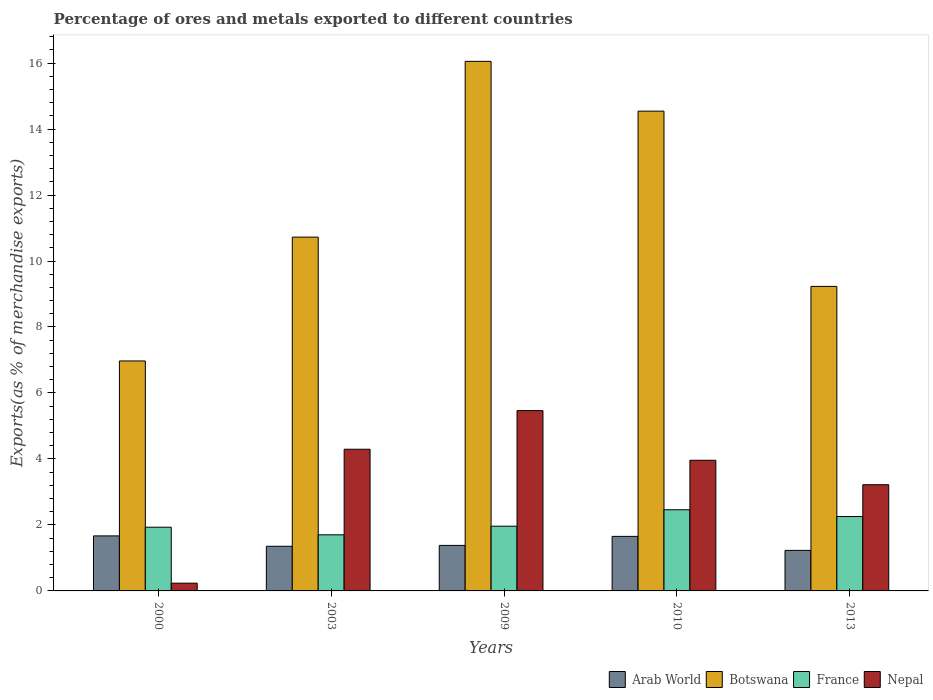Are the number of bars on each tick of the X-axis equal?
Your answer should be very brief. Yes. How many bars are there on the 1st tick from the left?
Offer a terse response. 4. How many bars are there on the 5th tick from the right?
Provide a short and direct response. 4. What is the percentage of exports to different countries in Nepal in 2009?
Ensure brevity in your answer.  5.47. Across all years, what is the maximum percentage of exports to different countries in Arab World?
Keep it short and to the point. 1.67. Across all years, what is the minimum percentage of exports to different countries in France?
Make the answer very short. 1.7. In which year was the percentage of exports to different countries in France minimum?
Keep it short and to the point. 2003. What is the total percentage of exports to different countries in Botswana in the graph?
Provide a short and direct response. 57.52. What is the difference between the percentage of exports to different countries in Nepal in 2000 and that in 2009?
Your response must be concise. -5.23. What is the difference between the percentage of exports to different countries in Arab World in 2003 and the percentage of exports to different countries in France in 2009?
Provide a short and direct response. -0.61. What is the average percentage of exports to different countries in Nepal per year?
Make the answer very short. 3.43. In the year 2003, what is the difference between the percentage of exports to different countries in Nepal and percentage of exports to different countries in France?
Offer a terse response. 2.59. In how many years, is the percentage of exports to different countries in France greater than 3.2 %?
Give a very brief answer. 0. What is the ratio of the percentage of exports to different countries in Arab World in 2000 to that in 2010?
Give a very brief answer. 1.01. Is the difference between the percentage of exports to different countries in Nepal in 2000 and 2013 greater than the difference between the percentage of exports to different countries in France in 2000 and 2013?
Your answer should be compact. No. What is the difference between the highest and the second highest percentage of exports to different countries in Botswana?
Keep it short and to the point. 1.51. What is the difference between the highest and the lowest percentage of exports to different countries in Botswana?
Make the answer very short. 9.08. Is it the case that in every year, the sum of the percentage of exports to different countries in Botswana and percentage of exports to different countries in Nepal is greater than the sum of percentage of exports to different countries in Arab World and percentage of exports to different countries in France?
Provide a short and direct response. Yes. What does the 4th bar from the left in 2003 represents?
Offer a very short reply. Nepal. What does the 3rd bar from the right in 2003 represents?
Your response must be concise. Botswana. How many bars are there?
Your response must be concise. 20. How many years are there in the graph?
Give a very brief answer. 5. What is the difference between two consecutive major ticks on the Y-axis?
Your answer should be very brief. 2. Does the graph contain any zero values?
Ensure brevity in your answer.  No. Does the graph contain grids?
Offer a very short reply. No. Where does the legend appear in the graph?
Your answer should be compact. Bottom right. How are the legend labels stacked?
Provide a succinct answer. Horizontal. What is the title of the graph?
Give a very brief answer. Percentage of ores and metals exported to different countries. What is the label or title of the X-axis?
Offer a very short reply. Years. What is the label or title of the Y-axis?
Your answer should be very brief. Exports(as % of merchandise exports). What is the Exports(as % of merchandise exports) of Arab World in 2000?
Provide a succinct answer. 1.67. What is the Exports(as % of merchandise exports) in Botswana in 2000?
Your response must be concise. 6.97. What is the Exports(as % of merchandise exports) in France in 2000?
Give a very brief answer. 1.93. What is the Exports(as % of merchandise exports) of Nepal in 2000?
Your answer should be compact. 0.23. What is the Exports(as % of merchandise exports) in Arab World in 2003?
Provide a succinct answer. 1.35. What is the Exports(as % of merchandise exports) in Botswana in 2003?
Your response must be concise. 10.72. What is the Exports(as % of merchandise exports) in France in 2003?
Provide a short and direct response. 1.7. What is the Exports(as % of merchandise exports) of Nepal in 2003?
Provide a short and direct response. 4.29. What is the Exports(as % of merchandise exports) in Arab World in 2009?
Your answer should be compact. 1.38. What is the Exports(as % of merchandise exports) in Botswana in 2009?
Offer a terse response. 16.05. What is the Exports(as % of merchandise exports) of France in 2009?
Provide a short and direct response. 1.96. What is the Exports(as % of merchandise exports) of Nepal in 2009?
Make the answer very short. 5.47. What is the Exports(as % of merchandise exports) of Arab World in 2010?
Offer a terse response. 1.65. What is the Exports(as % of merchandise exports) of Botswana in 2010?
Give a very brief answer. 14.54. What is the Exports(as % of merchandise exports) in France in 2010?
Keep it short and to the point. 2.46. What is the Exports(as % of merchandise exports) in Nepal in 2010?
Provide a succinct answer. 3.96. What is the Exports(as % of merchandise exports) of Arab World in 2013?
Offer a terse response. 1.23. What is the Exports(as % of merchandise exports) of Botswana in 2013?
Keep it short and to the point. 9.23. What is the Exports(as % of merchandise exports) in France in 2013?
Offer a very short reply. 2.25. What is the Exports(as % of merchandise exports) of Nepal in 2013?
Offer a terse response. 3.22. Across all years, what is the maximum Exports(as % of merchandise exports) in Arab World?
Give a very brief answer. 1.67. Across all years, what is the maximum Exports(as % of merchandise exports) of Botswana?
Offer a terse response. 16.05. Across all years, what is the maximum Exports(as % of merchandise exports) in France?
Your answer should be compact. 2.46. Across all years, what is the maximum Exports(as % of merchandise exports) in Nepal?
Offer a very short reply. 5.47. Across all years, what is the minimum Exports(as % of merchandise exports) of Arab World?
Offer a terse response. 1.23. Across all years, what is the minimum Exports(as % of merchandise exports) of Botswana?
Give a very brief answer. 6.97. Across all years, what is the minimum Exports(as % of merchandise exports) of France?
Make the answer very short. 1.7. Across all years, what is the minimum Exports(as % of merchandise exports) of Nepal?
Give a very brief answer. 0.23. What is the total Exports(as % of merchandise exports) of Arab World in the graph?
Provide a succinct answer. 7.28. What is the total Exports(as % of merchandise exports) in Botswana in the graph?
Make the answer very short. 57.52. What is the total Exports(as % of merchandise exports) in France in the graph?
Give a very brief answer. 10.31. What is the total Exports(as % of merchandise exports) in Nepal in the graph?
Your answer should be compact. 17.17. What is the difference between the Exports(as % of merchandise exports) in Arab World in 2000 and that in 2003?
Your answer should be compact. 0.31. What is the difference between the Exports(as % of merchandise exports) of Botswana in 2000 and that in 2003?
Your answer should be compact. -3.75. What is the difference between the Exports(as % of merchandise exports) of France in 2000 and that in 2003?
Provide a short and direct response. 0.23. What is the difference between the Exports(as % of merchandise exports) of Nepal in 2000 and that in 2003?
Ensure brevity in your answer.  -4.06. What is the difference between the Exports(as % of merchandise exports) in Arab World in 2000 and that in 2009?
Offer a very short reply. 0.29. What is the difference between the Exports(as % of merchandise exports) of Botswana in 2000 and that in 2009?
Make the answer very short. -9.08. What is the difference between the Exports(as % of merchandise exports) in France in 2000 and that in 2009?
Your response must be concise. -0.03. What is the difference between the Exports(as % of merchandise exports) of Nepal in 2000 and that in 2009?
Keep it short and to the point. -5.23. What is the difference between the Exports(as % of merchandise exports) in Arab World in 2000 and that in 2010?
Make the answer very short. 0.01. What is the difference between the Exports(as % of merchandise exports) of Botswana in 2000 and that in 2010?
Keep it short and to the point. -7.57. What is the difference between the Exports(as % of merchandise exports) of France in 2000 and that in 2010?
Your response must be concise. -0.53. What is the difference between the Exports(as % of merchandise exports) in Nepal in 2000 and that in 2010?
Ensure brevity in your answer.  -3.73. What is the difference between the Exports(as % of merchandise exports) in Arab World in 2000 and that in 2013?
Provide a succinct answer. 0.44. What is the difference between the Exports(as % of merchandise exports) in Botswana in 2000 and that in 2013?
Offer a terse response. -2.26. What is the difference between the Exports(as % of merchandise exports) of France in 2000 and that in 2013?
Offer a terse response. -0.32. What is the difference between the Exports(as % of merchandise exports) of Nepal in 2000 and that in 2013?
Your answer should be compact. -2.98. What is the difference between the Exports(as % of merchandise exports) of Arab World in 2003 and that in 2009?
Offer a very short reply. -0.03. What is the difference between the Exports(as % of merchandise exports) in Botswana in 2003 and that in 2009?
Give a very brief answer. -5.33. What is the difference between the Exports(as % of merchandise exports) in France in 2003 and that in 2009?
Provide a short and direct response. -0.26. What is the difference between the Exports(as % of merchandise exports) of Nepal in 2003 and that in 2009?
Your answer should be very brief. -1.17. What is the difference between the Exports(as % of merchandise exports) of Arab World in 2003 and that in 2010?
Provide a succinct answer. -0.3. What is the difference between the Exports(as % of merchandise exports) of Botswana in 2003 and that in 2010?
Your answer should be very brief. -3.82. What is the difference between the Exports(as % of merchandise exports) in France in 2003 and that in 2010?
Provide a short and direct response. -0.76. What is the difference between the Exports(as % of merchandise exports) in Nepal in 2003 and that in 2010?
Your answer should be compact. 0.33. What is the difference between the Exports(as % of merchandise exports) of Arab World in 2003 and that in 2013?
Your response must be concise. 0.12. What is the difference between the Exports(as % of merchandise exports) in Botswana in 2003 and that in 2013?
Your answer should be compact. 1.49. What is the difference between the Exports(as % of merchandise exports) in France in 2003 and that in 2013?
Provide a succinct answer. -0.55. What is the difference between the Exports(as % of merchandise exports) in Nepal in 2003 and that in 2013?
Offer a terse response. 1.07. What is the difference between the Exports(as % of merchandise exports) of Arab World in 2009 and that in 2010?
Ensure brevity in your answer.  -0.27. What is the difference between the Exports(as % of merchandise exports) in Botswana in 2009 and that in 2010?
Offer a very short reply. 1.51. What is the difference between the Exports(as % of merchandise exports) in France in 2009 and that in 2010?
Offer a very short reply. -0.5. What is the difference between the Exports(as % of merchandise exports) in Nepal in 2009 and that in 2010?
Your answer should be compact. 1.51. What is the difference between the Exports(as % of merchandise exports) in Arab World in 2009 and that in 2013?
Provide a succinct answer. 0.15. What is the difference between the Exports(as % of merchandise exports) in Botswana in 2009 and that in 2013?
Provide a short and direct response. 6.82. What is the difference between the Exports(as % of merchandise exports) in France in 2009 and that in 2013?
Give a very brief answer. -0.29. What is the difference between the Exports(as % of merchandise exports) in Nepal in 2009 and that in 2013?
Your answer should be very brief. 2.25. What is the difference between the Exports(as % of merchandise exports) of Arab World in 2010 and that in 2013?
Offer a terse response. 0.42. What is the difference between the Exports(as % of merchandise exports) of Botswana in 2010 and that in 2013?
Offer a terse response. 5.31. What is the difference between the Exports(as % of merchandise exports) of France in 2010 and that in 2013?
Provide a short and direct response. 0.21. What is the difference between the Exports(as % of merchandise exports) of Nepal in 2010 and that in 2013?
Provide a succinct answer. 0.74. What is the difference between the Exports(as % of merchandise exports) in Arab World in 2000 and the Exports(as % of merchandise exports) in Botswana in 2003?
Ensure brevity in your answer.  -9.06. What is the difference between the Exports(as % of merchandise exports) in Arab World in 2000 and the Exports(as % of merchandise exports) in France in 2003?
Offer a terse response. -0.03. What is the difference between the Exports(as % of merchandise exports) of Arab World in 2000 and the Exports(as % of merchandise exports) of Nepal in 2003?
Offer a very short reply. -2.63. What is the difference between the Exports(as % of merchandise exports) in Botswana in 2000 and the Exports(as % of merchandise exports) in France in 2003?
Your response must be concise. 5.27. What is the difference between the Exports(as % of merchandise exports) in Botswana in 2000 and the Exports(as % of merchandise exports) in Nepal in 2003?
Offer a terse response. 2.68. What is the difference between the Exports(as % of merchandise exports) of France in 2000 and the Exports(as % of merchandise exports) of Nepal in 2003?
Offer a terse response. -2.36. What is the difference between the Exports(as % of merchandise exports) of Arab World in 2000 and the Exports(as % of merchandise exports) of Botswana in 2009?
Give a very brief answer. -14.38. What is the difference between the Exports(as % of merchandise exports) of Arab World in 2000 and the Exports(as % of merchandise exports) of France in 2009?
Offer a very short reply. -0.29. What is the difference between the Exports(as % of merchandise exports) of Arab World in 2000 and the Exports(as % of merchandise exports) of Nepal in 2009?
Your answer should be compact. -3.8. What is the difference between the Exports(as % of merchandise exports) in Botswana in 2000 and the Exports(as % of merchandise exports) in France in 2009?
Your response must be concise. 5.01. What is the difference between the Exports(as % of merchandise exports) of Botswana in 2000 and the Exports(as % of merchandise exports) of Nepal in 2009?
Give a very brief answer. 1.51. What is the difference between the Exports(as % of merchandise exports) in France in 2000 and the Exports(as % of merchandise exports) in Nepal in 2009?
Your answer should be very brief. -3.53. What is the difference between the Exports(as % of merchandise exports) of Arab World in 2000 and the Exports(as % of merchandise exports) of Botswana in 2010?
Make the answer very short. -12.88. What is the difference between the Exports(as % of merchandise exports) of Arab World in 2000 and the Exports(as % of merchandise exports) of France in 2010?
Ensure brevity in your answer.  -0.79. What is the difference between the Exports(as % of merchandise exports) of Arab World in 2000 and the Exports(as % of merchandise exports) of Nepal in 2010?
Provide a succinct answer. -2.29. What is the difference between the Exports(as % of merchandise exports) of Botswana in 2000 and the Exports(as % of merchandise exports) of France in 2010?
Your answer should be very brief. 4.51. What is the difference between the Exports(as % of merchandise exports) of Botswana in 2000 and the Exports(as % of merchandise exports) of Nepal in 2010?
Give a very brief answer. 3.01. What is the difference between the Exports(as % of merchandise exports) in France in 2000 and the Exports(as % of merchandise exports) in Nepal in 2010?
Offer a very short reply. -2.03. What is the difference between the Exports(as % of merchandise exports) of Arab World in 2000 and the Exports(as % of merchandise exports) of Botswana in 2013?
Offer a very short reply. -7.56. What is the difference between the Exports(as % of merchandise exports) in Arab World in 2000 and the Exports(as % of merchandise exports) in France in 2013?
Make the answer very short. -0.59. What is the difference between the Exports(as % of merchandise exports) of Arab World in 2000 and the Exports(as % of merchandise exports) of Nepal in 2013?
Your response must be concise. -1.55. What is the difference between the Exports(as % of merchandise exports) in Botswana in 2000 and the Exports(as % of merchandise exports) in France in 2013?
Your answer should be compact. 4.72. What is the difference between the Exports(as % of merchandise exports) in Botswana in 2000 and the Exports(as % of merchandise exports) in Nepal in 2013?
Provide a succinct answer. 3.75. What is the difference between the Exports(as % of merchandise exports) of France in 2000 and the Exports(as % of merchandise exports) of Nepal in 2013?
Your answer should be compact. -1.29. What is the difference between the Exports(as % of merchandise exports) of Arab World in 2003 and the Exports(as % of merchandise exports) of Botswana in 2009?
Your answer should be very brief. -14.7. What is the difference between the Exports(as % of merchandise exports) in Arab World in 2003 and the Exports(as % of merchandise exports) in France in 2009?
Provide a succinct answer. -0.61. What is the difference between the Exports(as % of merchandise exports) of Arab World in 2003 and the Exports(as % of merchandise exports) of Nepal in 2009?
Offer a very short reply. -4.11. What is the difference between the Exports(as % of merchandise exports) of Botswana in 2003 and the Exports(as % of merchandise exports) of France in 2009?
Ensure brevity in your answer.  8.76. What is the difference between the Exports(as % of merchandise exports) of Botswana in 2003 and the Exports(as % of merchandise exports) of Nepal in 2009?
Provide a succinct answer. 5.26. What is the difference between the Exports(as % of merchandise exports) of France in 2003 and the Exports(as % of merchandise exports) of Nepal in 2009?
Offer a terse response. -3.76. What is the difference between the Exports(as % of merchandise exports) of Arab World in 2003 and the Exports(as % of merchandise exports) of Botswana in 2010?
Your answer should be compact. -13.19. What is the difference between the Exports(as % of merchandise exports) in Arab World in 2003 and the Exports(as % of merchandise exports) in France in 2010?
Provide a succinct answer. -1.11. What is the difference between the Exports(as % of merchandise exports) of Arab World in 2003 and the Exports(as % of merchandise exports) of Nepal in 2010?
Your answer should be compact. -2.61. What is the difference between the Exports(as % of merchandise exports) in Botswana in 2003 and the Exports(as % of merchandise exports) in France in 2010?
Your answer should be compact. 8.26. What is the difference between the Exports(as % of merchandise exports) of Botswana in 2003 and the Exports(as % of merchandise exports) of Nepal in 2010?
Your response must be concise. 6.76. What is the difference between the Exports(as % of merchandise exports) of France in 2003 and the Exports(as % of merchandise exports) of Nepal in 2010?
Your answer should be very brief. -2.26. What is the difference between the Exports(as % of merchandise exports) of Arab World in 2003 and the Exports(as % of merchandise exports) of Botswana in 2013?
Your answer should be very brief. -7.88. What is the difference between the Exports(as % of merchandise exports) of Arab World in 2003 and the Exports(as % of merchandise exports) of France in 2013?
Keep it short and to the point. -0.9. What is the difference between the Exports(as % of merchandise exports) of Arab World in 2003 and the Exports(as % of merchandise exports) of Nepal in 2013?
Keep it short and to the point. -1.87. What is the difference between the Exports(as % of merchandise exports) in Botswana in 2003 and the Exports(as % of merchandise exports) in France in 2013?
Keep it short and to the point. 8.47. What is the difference between the Exports(as % of merchandise exports) in Botswana in 2003 and the Exports(as % of merchandise exports) in Nepal in 2013?
Make the answer very short. 7.5. What is the difference between the Exports(as % of merchandise exports) in France in 2003 and the Exports(as % of merchandise exports) in Nepal in 2013?
Give a very brief answer. -1.52. What is the difference between the Exports(as % of merchandise exports) of Arab World in 2009 and the Exports(as % of merchandise exports) of Botswana in 2010?
Give a very brief answer. -13.16. What is the difference between the Exports(as % of merchandise exports) of Arab World in 2009 and the Exports(as % of merchandise exports) of France in 2010?
Offer a terse response. -1.08. What is the difference between the Exports(as % of merchandise exports) in Arab World in 2009 and the Exports(as % of merchandise exports) in Nepal in 2010?
Offer a very short reply. -2.58. What is the difference between the Exports(as % of merchandise exports) of Botswana in 2009 and the Exports(as % of merchandise exports) of France in 2010?
Your answer should be very brief. 13.59. What is the difference between the Exports(as % of merchandise exports) in Botswana in 2009 and the Exports(as % of merchandise exports) in Nepal in 2010?
Make the answer very short. 12.09. What is the difference between the Exports(as % of merchandise exports) of France in 2009 and the Exports(as % of merchandise exports) of Nepal in 2010?
Ensure brevity in your answer.  -2. What is the difference between the Exports(as % of merchandise exports) in Arab World in 2009 and the Exports(as % of merchandise exports) in Botswana in 2013?
Offer a terse response. -7.85. What is the difference between the Exports(as % of merchandise exports) in Arab World in 2009 and the Exports(as % of merchandise exports) in France in 2013?
Your answer should be very brief. -0.87. What is the difference between the Exports(as % of merchandise exports) in Arab World in 2009 and the Exports(as % of merchandise exports) in Nepal in 2013?
Provide a succinct answer. -1.84. What is the difference between the Exports(as % of merchandise exports) of Botswana in 2009 and the Exports(as % of merchandise exports) of France in 2013?
Offer a very short reply. 13.8. What is the difference between the Exports(as % of merchandise exports) of Botswana in 2009 and the Exports(as % of merchandise exports) of Nepal in 2013?
Your response must be concise. 12.83. What is the difference between the Exports(as % of merchandise exports) in France in 2009 and the Exports(as % of merchandise exports) in Nepal in 2013?
Give a very brief answer. -1.26. What is the difference between the Exports(as % of merchandise exports) in Arab World in 2010 and the Exports(as % of merchandise exports) in Botswana in 2013?
Keep it short and to the point. -7.58. What is the difference between the Exports(as % of merchandise exports) of Arab World in 2010 and the Exports(as % of merchandise exports) of France in 2013?
Keep it short and to the point. -0.6. What is the difference between the Exports(as % of merchandise exports) of Arab World in 2010 and the Exports(as % of merchandise exports) of Nepal in 2013?
Keep it short and to the point. -1.57. What is the difference between the Exports(as % of merchandise exports) of Botswana in 2010 and the Exports(as % of merchandise exports) of France in 2013?
Your response must be concise. 12.29. What is the difference between the Exports(as % of merchandise exports) in Botswana in 2010 and the Exports(as % of merchandise exports) in Nepal in 2013?
Give a very brief answer. 11.32. What is the difference between the Exports(as % of merchandise exports) of France in 2010 and the Exports(as % of merchandise exports) of Nepal in 2013?
Make the answer very short. -0.76. What is the average Exports(as % of merchandise exports) in Arab World per year?
Your answer should be compact. 1.46. What is the average Exports(as % of merchandise exports) in Botswana per year?
Make the answer very short. 11.5. What is the average Exports(as % of merchandise exports) of France per year?
Provide a succinct answer. 2.06. What is the average Exports(as % of merchandise exports) in Nepal per year?
Your response must be concise. 3.43. In the year 2000, what is the difference between the Exports(as % of merchandise exports) in Arab World and Exports(as % of merchandise exports) in Botswana?
Offer a terse response. -5.3. In the year 2000, what is the difference between the Exports(as % of merchandise exports) in Arab World and Exports(as % of merchandise exports) in France?
Keep it short and to the point. -0.26. In the year 2000, what is the difference between the Exports(as % of merchandise exports) in Arab World and Exports(as % of merchandise exports) in Nepal?
Make the answer very short. 1.43. In the year 2000, what is the difference between the Exports(as % of merchandise exports) in Botswana and Exports(as % of merchandise exports) in France?
Your answer should be very brief. 5.04. In the year 2000, what is the difference between the Exports(as % of merchandise exports) of Botswana and Exports(as % of merchandise exports) of Nepal?
Ensure brevity in your answer.  6.74. In the year 2000, what is the difference between the Exports(as % of merchandise exports) of France and Exports(as % of merchandise exports) of Nepal?
Keep it short and to the point. 1.7. In the year 2003, what is the difference between the Exports(as % of merchandise exports) in Arab World and Exports(as % of merchandise exports) in Botswana?
Give a very brief answer. -9.37. In the year 2003, what is the difference between the Exports(as % of merchandise exports) in Arab World and Exports(as % of merchandise exports) in France?
Offer a terse response. -0.35. In the year 2003, what is the difference between the Exports(as % of merchandise exports) in Arab World and Exports(as % of merchandise exports) in Nepal?
Keep it short and to the point. -2.94. In the year 2003, what is the difference between the Exports(as % of merchandise exports) in Botswana and Exports(as % of merchandise exports) in France?
Offer a very short reply. 9.02. In the year 2003, what is the difference between the Exports(as % of merchandise exports) in Botswana and Exports(as % of merchandise exports) in Nepal?
Give a very brief answer. 6.43. In the year 2003, what is the difference between the Exports(as % of merchandise exports) of France and Exports(as % of merchandise exports) of Nepal?
Make the answer very short. -2.59. In the year 2009, what is the difference between the Exports(as % of merchandise exports) in Arab World and Exports(as % of merchandise exports) in Botswana?
Ensure brevity in your answer.  -14.67. In the year 2009, what is the difference between the Exports(as % of merchandise exports) of Arab World and Exports(as % of merchandise exports) of France?
Your response must be concise. -0.58. In the year 2009, what is the difference between the Exports(as % of merchandise exports) of Arab World and Exports(as % of merchandise exports) of Nepal?
Provide a succinct answer. -4.09. In the year 2009, what is the difference between the Exports(as % of merchandise exports) of Botswana and Exports(as % of merchandise exports) of France?
Provide a short and direct response. 14.09. In the year 2009, what is the difference between the Exports(as % of merchandise exports) in Botswana and Exports(as % of merchandise exports) in Nepal?
Provide a succinct answer. 10.59. In the year 2009, what is the difference between the Exports(as % of merchandise exports) of France and Exports(as % of merchandise exports) of Nepal?
Your answer should be very brief. -3.5. In the year 2010, what is the difference between the Exports(as % of merchandise exports) of Arab World and Exports(as % of merchandise exports) of Botswana?
Provide a short and direct response. -12.89. In the year 2010, what is the difference between the Exports(as % of merchandise exports) of Arab World and Exports(as % of merchandise exports) of France?
Your answer should be compact. -0.81. In the year 2010, what is the difference between the Exports(as % of merchandise exports) in Arab World and Exports(as % of merchandise exports) in Nepal?
Provide a short and direct response. -2.31. In the year 2010, what is the difference between the Exports(as % of merchandise exports) of Botswana and Exports(as % of merchandise exports) of France?
Your response must be concise. 12.08. In the year 2010, what is the difference between the Exports(as % of merchandise exports) of Botswana and Exports(as % of merchandise exports) of Nepal?
Your answer should be compact. 10.58. In the year 2010, what is the difference between the Exports(as % of merchandise exports) in France and Exports(as % of merchandise exports) in Nepal?
Your answer should be very brief. -1.5. In the year 2013, what is the difference between the Exports(as % of merchandise exports) of Arab World and Exports(as % of merchandise exports) of Botswana?
Provide a succinct answer. -8. In the year 2013, what is the difference between the Exports(as % of merchandise exports) of Arab World and Exports(as % of merchandise exports) of France?
Provide a succinct answer. -1.03. In the year 2013, what is the difference between the Exports(as % of merchandise exports) in Arab World and Exports(as % of merchandise exports) in Nepal?
Keep it short and to the point. -1.99. In the year 2013, what is the difference between the Exports(as % of merchandise exports) in Botswana and Exports(as % of merchandise exports) in France?
Provide a short and direct response. 6.98. In the year 2013, what is the difference between the Exports(as % of merchandise exports) in Botswana and Exports(as % of merchandise exports) in Nepal?
Offer a very short reply. 6.01. In the year 2013, what is the difference between the Exports(as % of merchandise exports) of France and Exports(as % of merchandise exports) of Nepal?
Ensure brevity in your answer.  -0.96. What is the ratio of the Exports(as % of merchandise exports) of Arab World in 2000 to that in 2003?
Offer a very short reply. 1.23. What is the ratio of the Exports(as % of merchandise exports) of Botswana in 2000 to that in 2003?
Offer a very short reply. 0.65. What is the ratio of the Exports(as % of merchandise exports) in France in 2000 to that in 2003?
Ensure brevity in your answer.  1.14. What is the ratio of the Exports(as % of merchandise exports) in Nepal in 2000 to that in 2003?
Keep it short and to the point. 0.05. What is the ratio of the Exports(as % of merchandise exports) of Arab World in 2000 to that in 2009?
Give a very brief answer. 1.21. What is the ratio of the Exports(as % of merchandise exports) in Botswana in 2000 to that in 2009?
Your answer should be compact. 0.43. What is the ratio of the Exports(as % of merchandise exports) of France in 2000 to that in 2009?
Provide a succinct answer. 0.98. What is the ratio of the Exports(as % of merchandise exports) in Nepal in 2000 to that in 2009?
Offer a terse response. 0.04. What is the ratio of the Exports(as % of merchandise exports) of Arab World in 2000 to that in 2010?
Make the answer very short. 1.01. What is the ratio of the Exports(as % of merchandise exports) of Botswana in 2000 to that in 2010?
Ensure brevity in your answer.  0.48. What is the ratio of the Exports(as % of merchandise exports) of France in 2000 to that in 2010?
Provide a succinct answer. 0.79. What is the ratio of the Exports(as % of merchandise exports) in Nepal in 2000 to that in 2010?
Your answer should be compact. 0.06. What is the ratio of the Exports(as % of merchandise exports) in Arab World in 2000 to that in 2013?
Give a very brief answer. 1.36. What is the ratio of the Exports(as % of merchandise exports) of Botswana in 2000 to that in 2013?
Ensure brevity in your answer.  0.76. What is the ratio of the Exports(as % of merchandise exports) of France in 2000 to that in 2013?
Provide a short and direct response. 0.86. What is the ratio of the Exports(as % of merchandise exports) of Nepal in 2000 to that in 2013?
Make the answer very short. 0.07. What is the ratio of the Exports(as % of merchandise exports) of Arab World in 2003 to that in 2009?
Provide a succinct answer. 0.98. What is the ratio of the Exports(as % of merchandise exports) of Botswana in 2003 to that in 2009?
Make the answer very short. 0.67. What is the ratio of the Exports(as % of merchandise exports) of France in 2003 to that in 2009?
Ensure brevity in your answer.  0.87. What is the ratio of the Exports(as % of merchandise exports) in Nepal in 2003 to that in 2009?
Keep it short and to the point. 0.79. What is the ratio of the Exports(as % of merchandise exports) in Arab World in 2003 to that in 2010?
Your response must be concise. 0.82. What is the ratio of the Exports(as % of merchandise exports) in Botswana in 2003 to that in 2010?
Offer a very short reply. 0.74. What is the ratio of the Exports(as % of merchandise exports) in France in 2003 to that in 2010?
Make the answer very short. 0.69. What is the ratio of the Exports(as % of merchandise exports) of Nepal in 2003 to that in 2010?
Give a very brief answer. 1.08. What is the ratio of the Exports(as % of merchandise exports) in Arab World in 2003 to that in 2013?
Ensure brevity in your answer.  1.1. What is the ratio of the Exports(as % of merchandise exports) in Botswana in 2003 to that in 2013?
Your answer should be very brief. 1.16. What is the ratio of the Exports(as % of merchandise exports) of France in 2003 to that in 2013?
Ensure brevity in your answer.  0.75. What is the ratio of the Exports(as % of merchandise exports) of Nepal in 2003 to that in 2013?
Provide a short and direct response. 1.33. What is the ratio of the Exports(as % of merchandise exports) of Arab World in 2009 to that in 2010?
Provide a short and direct response. 0.83. What is the ratio of the Exports(as % of merchandise exports) of Botswana in 2009 to that in 2010?
Ensure brevity in your answer.  1.1. What is the ratio of the Exports(as % of merchandise exports) of France in 2009 to that in 2010?
Provide a succinct answer. 0.8. What is the ratio of the Exports(as % of merchandise exports) of Nepal in 2009 to that in 2010?
Provide a succinct answer. 1.38. What is the ratio of the Exports(as % of merchandise exports) of Arab World in 2009 to that in 2013?
Provide a succinct answer. 1.12. What is the ratio of the Exports(as % of merchandise exports) in Botswana in 2009 to that in 2013?
Ensure brevity in your answer.  1.74. What is the ratio of the Exports(as % of merchandise exports) in France in 2009 to that in 2013?
Offer a very short reply. 0.87. What is the ratio of the Exports(as % of merchandise exports) of Nepal in 2009 to that in 2013?
Offer a very short reply. 1.7. What is the ratio of the Exports(as % of merchandise exports) of Arab World in 2010 to that in 2013?
Keep it short and to the point. 1.35. What is the ratio of the Exports(as % of merchandise exports) in Botswana in 2010 to that in 2013?
Offer a terse response. 1.58. What is the ratio of the Exports(as % of merchandise exports) in France in 2010 to that in 2013?
Offer a very short reply. 1.09. What is the ratio of the Exports(as % of merchandise exports) of Nepal in 2010 to that in 2013?
Ensure brevity in your answer.  1.23. What is the difference between the highest and the second highest Exports(as % of merchandise exports) of Arab World?
Make the answer very short. 0.01. What is the difference between the highest and the second highest Exports(as % of merchandise exports) of Botswana?
Give a very brief answer. 1.51. What is the difference between the highest and the second highest Exports(as % of merchandise exports) in France?
Provide a succinct answer. 0.21. What is the difference between the highest and the second highest Exports(as % of merchandise exports) of Nepal?
Offer a very short reply. 1.17. What is the difference between the highest and the lowest Exports(as % of merchandise exports) in Arab World?
Your answer should be very brief. 0.44. What is the difference between the highest and the lowest Exports(as % of merchandise exports) in Botswana?
Your answer should be compact. 9.08. What is the difference between the highest and the lowest Exports(as % of merchandise exports) in France?
Your response must be concise. 0.76. What is the difference between the highest and the lowest Exports(as % of merchandise exports) in Nepal?
Your answer should be very brief. 5.23. 